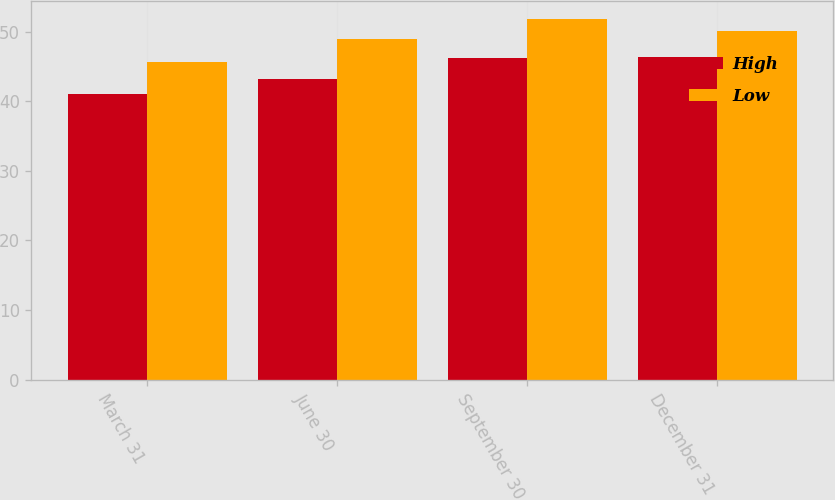Convert chart. <chart><loc_0><loc_0><loc_500><loc_500><stacked_bar_chart><ecel><fcel>March 31<fcel>June 30<fcel>September 30<fcel>December 31<nl><fcel>High<fcel>41.1<fcel>43.15<fcel>46.25<fcel>46.35<nl><fcel>Low<fcel>45.69<fcel>48.98<fcel>51.84<fcel>50.12<nl></chart> 